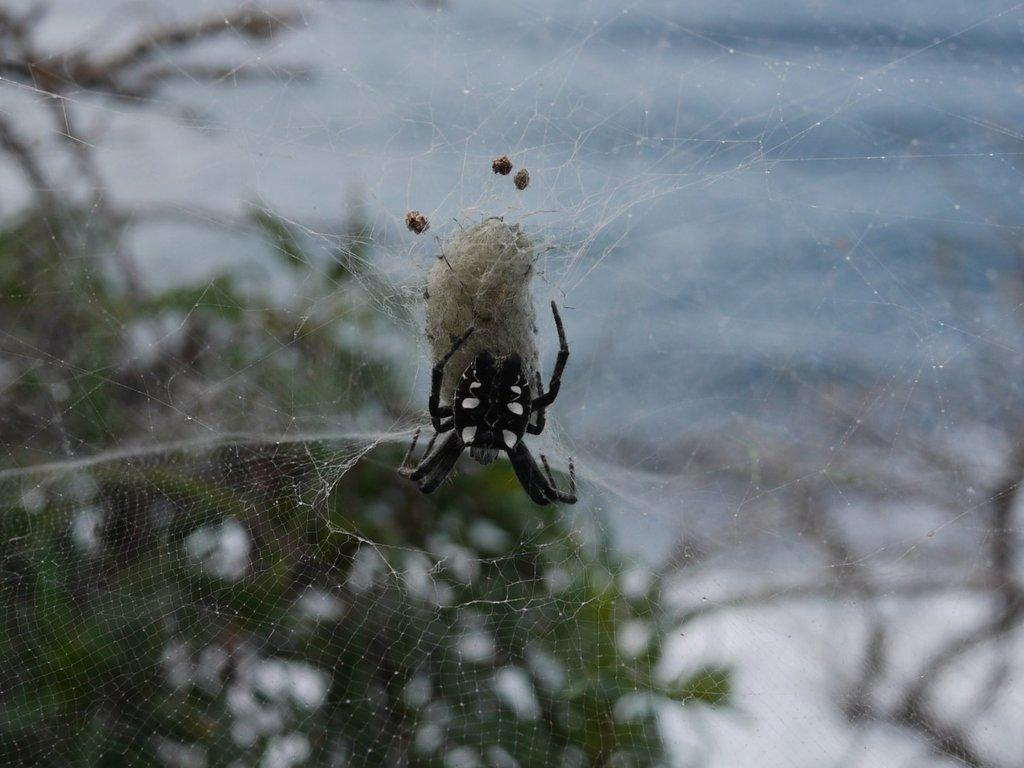What is the main subject of the image? There is a spider in the image. Where is the spider located? The spider is on a web. Can you describe the background of the image? The background of the image is blurred. Is there a swing visible in the image? No, there is no swing present in the image. Can you see a glove in the image? No, there is no glove present in the image. 